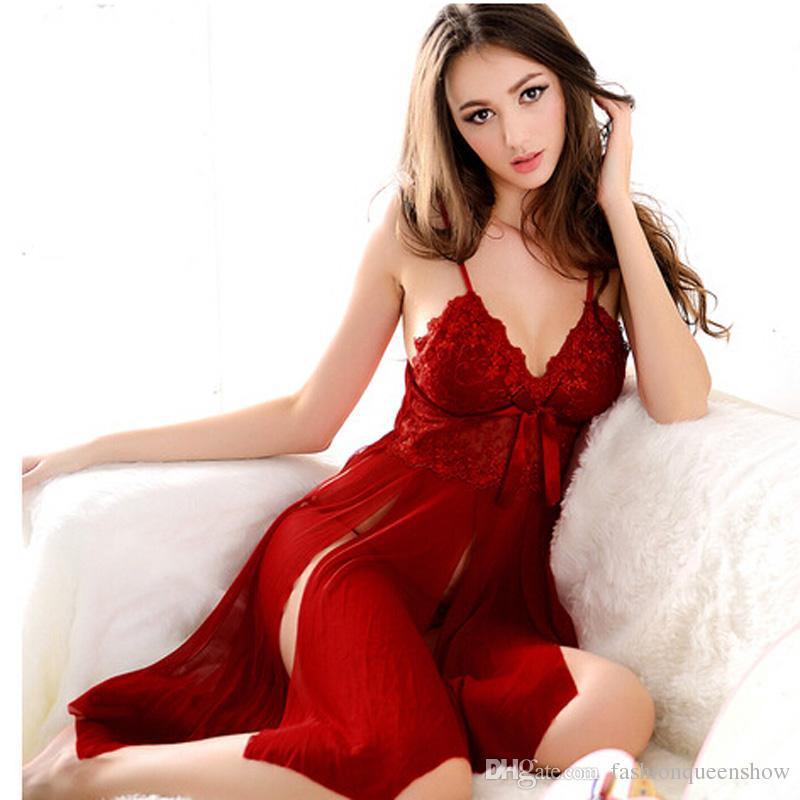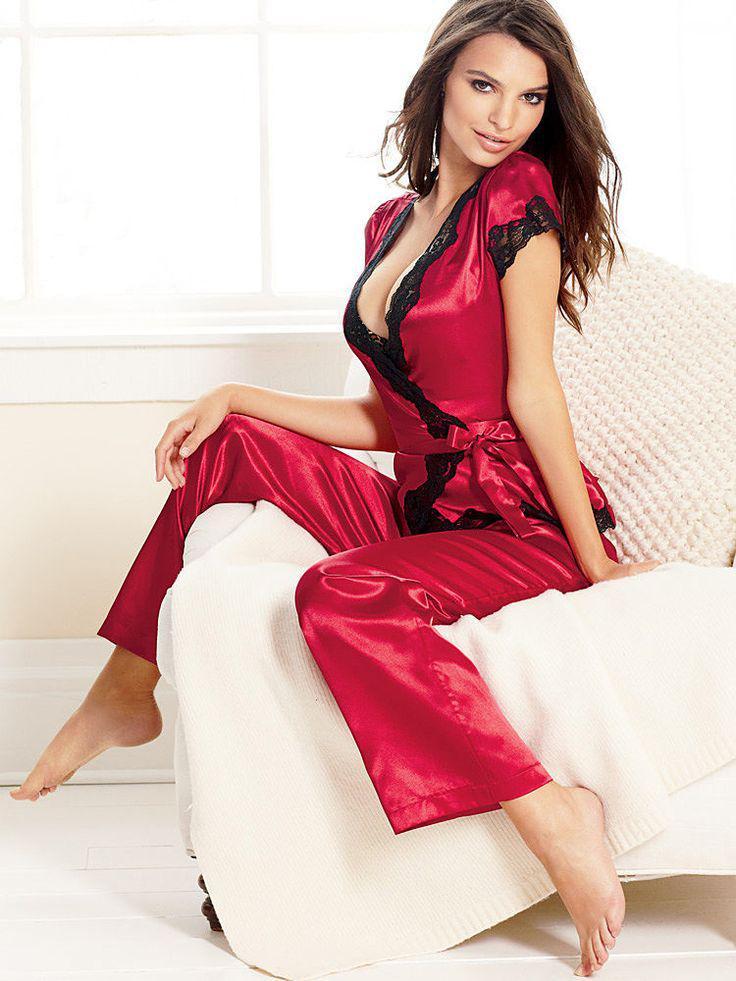The first image is the image on the left, the second image is the image on the right. Analyze the images presented: Is the assertion "At least one image shows a woman standing." valid? Answer yes or no. No. The first image is the image on the left, the second image is the image on the right. Given the left and right images, does the statement "The image on the right has a model standing on her feet wearing lingerie." hold true? Answer yes or no. No. 